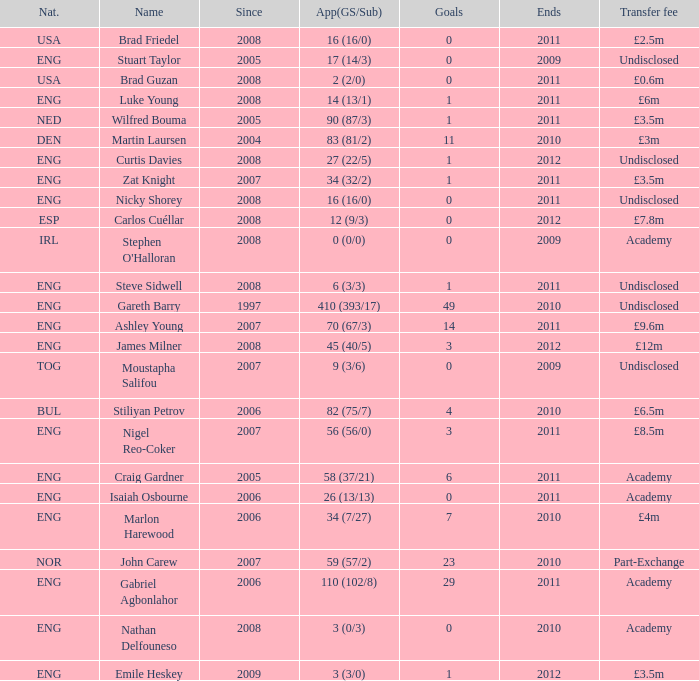5m, what is the total outcome? 2011.0. 